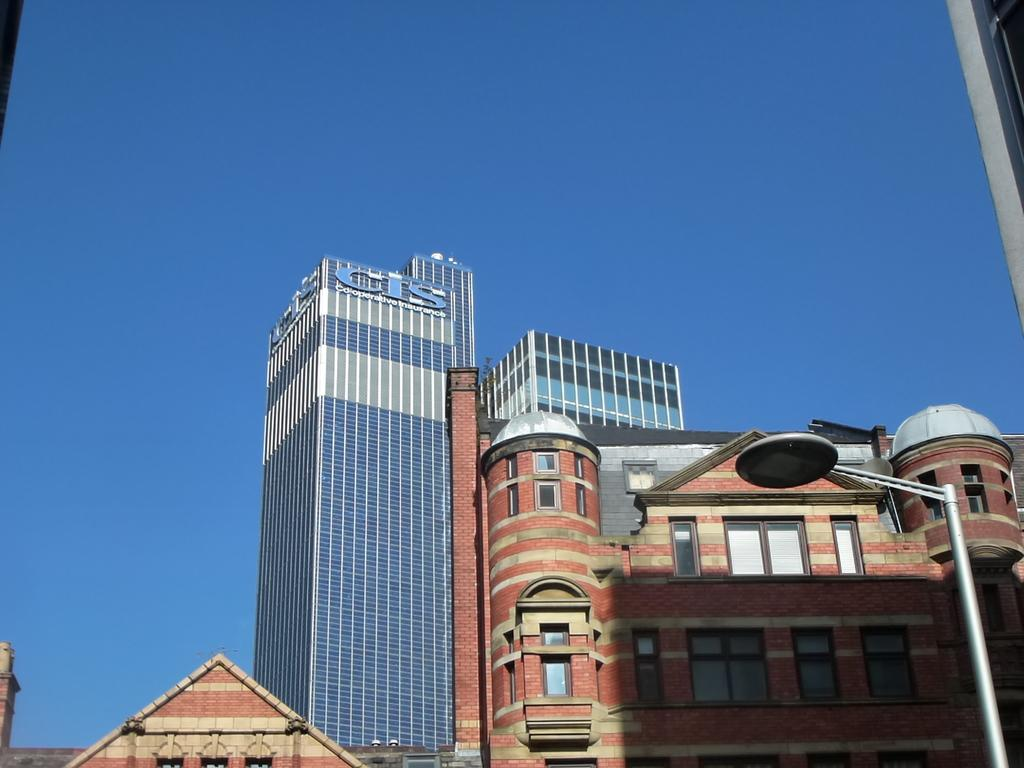What type of structures can be seen in the image? There are buildings in the image. What feature is visible on the buildings? Windows are visible in the image. What type of street furniture is present in the image? Street poles are present in the image. What type of illumination is visible in the image? Street lights are visible in the image. What part of the natural environment is visible in the image? The sky is visible in the image. What type of bread is being served on the throne in the image? There is no throne or bread present in the image. 